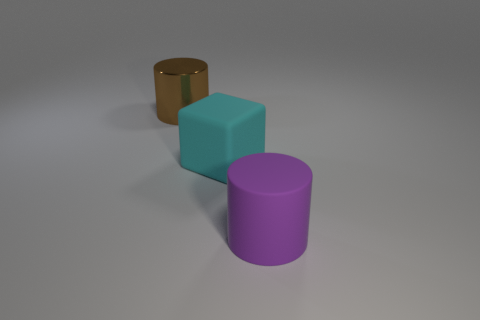Subtract all brown cylinders. How many cylinders are left? 1 Add 2 green rubber cylinders. How many objects exist? 5 Subtract 1 cylinders. How many cylinders are left? 1 Subtract all green rubber cubes. Subtract all purple matte cylinders. How many objects are left? 2 Add 1 cyan rubber blocks. How many cyan rubber blocks are left? 2 Add 1 big brown shiny cylinders. How many big brown shiny cylinders exist? 2 Subtract 0 green cubes. How many objects are left? 3 Subtract all cylinders. How many objects are left? 1 Subtract all red cylinders. Subtract all brown spheres. How many cylinders are left? 2 Subtract all red spheres. How many gray cylinders are left? 0 